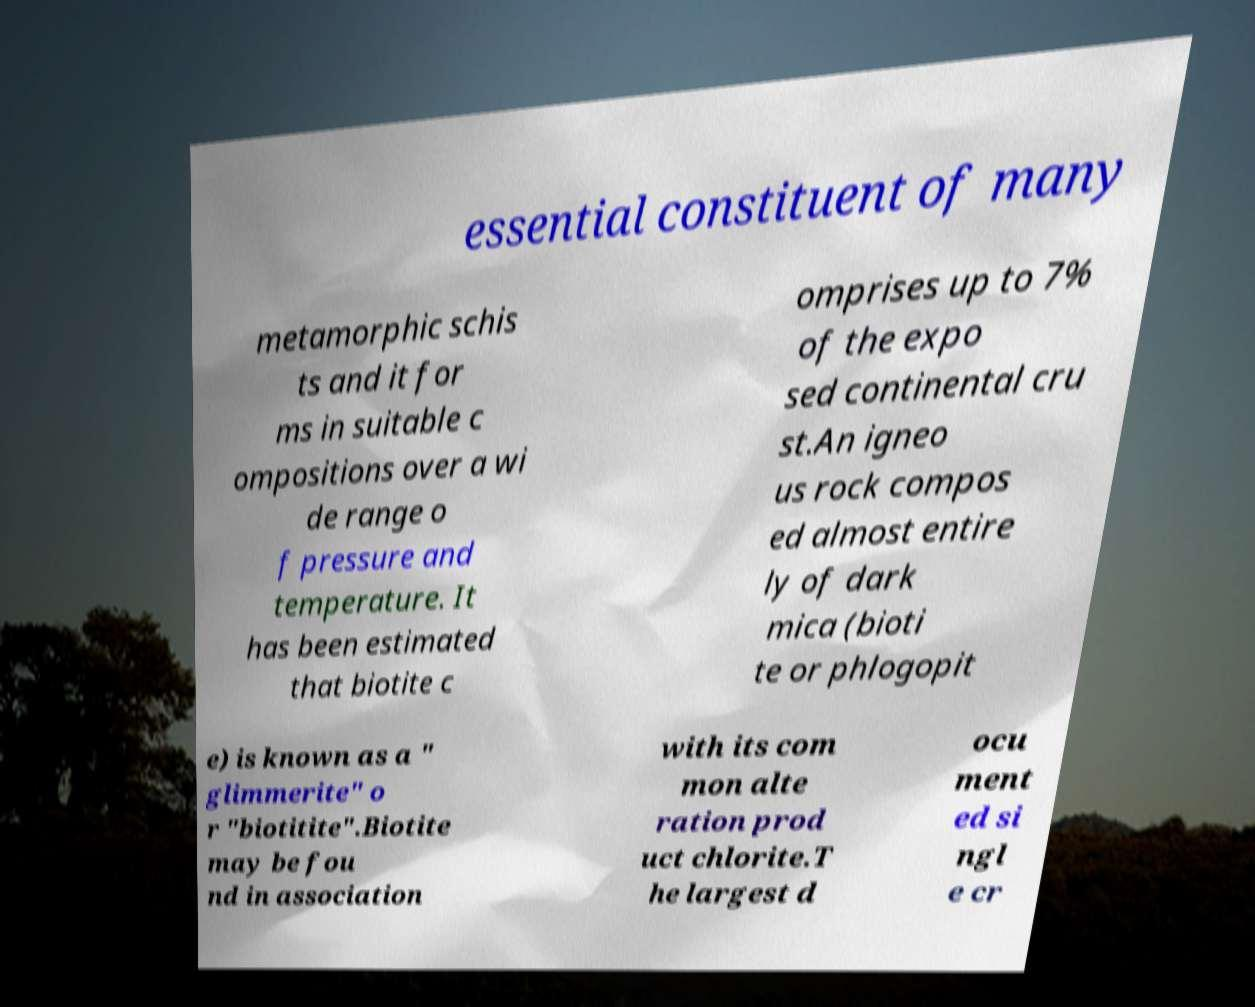Please read and relay the text visible in this image. What does it say? essential constituent of many metamorphic schis ts and it for ms in suitable c ompositions over a wi de range o f pressure and temperature. It has been estimated that biotite c omprises up to 7% of the expo sed continental cru st.An igneo us rock compos ed almost entire ly of dark mica (bioti te or phlogopit e) is known as a " glimmerite" o r "biotitite".Biotite may be fou nd in association with its com mon alte ration prod uct chlorite.T he largest d ocu ment ed si ngl e cr 